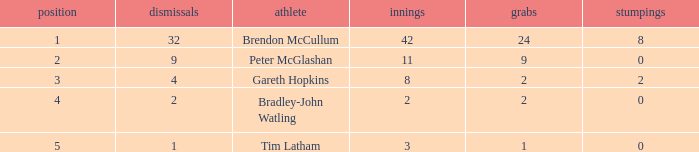Parse the table in full. {'header': ['position', 'dismissals', 'athlete', 'innings', 'grabs', 'stumpings'], 'rows': [['1', '32', 'Brendon McCullum', '42', '24', '8'], ['2', '9', 'Peter McGlashan', '11', '9', '0'], ['3', '4', 'Gareth Hopkins', '8', '2', '2'], ['4', '2', 'Bradley-John Watling', '2', '2', '0'], ['5', '1', 'Tim Latham', '3', '1', '0']]} How many stumpings did the player Tim Latham have? 0.0. 